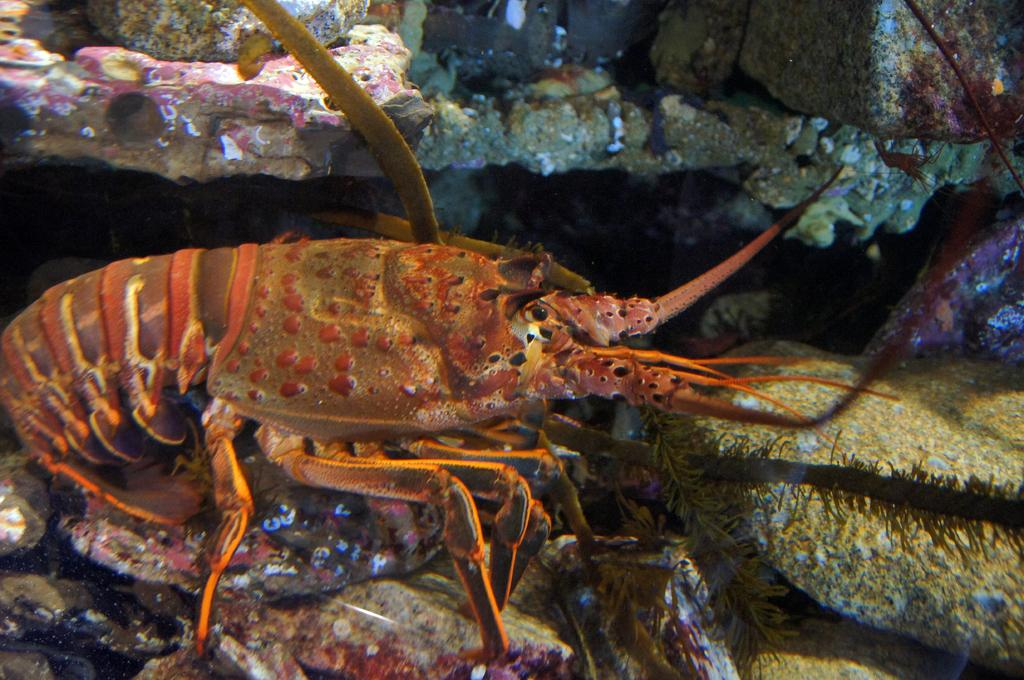What type of animal is in the image? The type of animal cannot be determined from the provided facts. What else can be seen in the image besides the animal? There are rocks and leaves in the image. What type of instrument is being played by the team in the image? There is no team or instrument present in the image. What is the stem of the plant in the image? There is no plant or stem present in the image. 